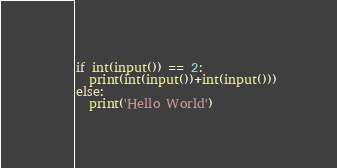Convert code to text. <code><loc_0><loc_0><loc_500><loc_500><_Python_>if int(input()) == 2:
  print(int(input())+int(input()))
else:
  print('Hello World')</code> 